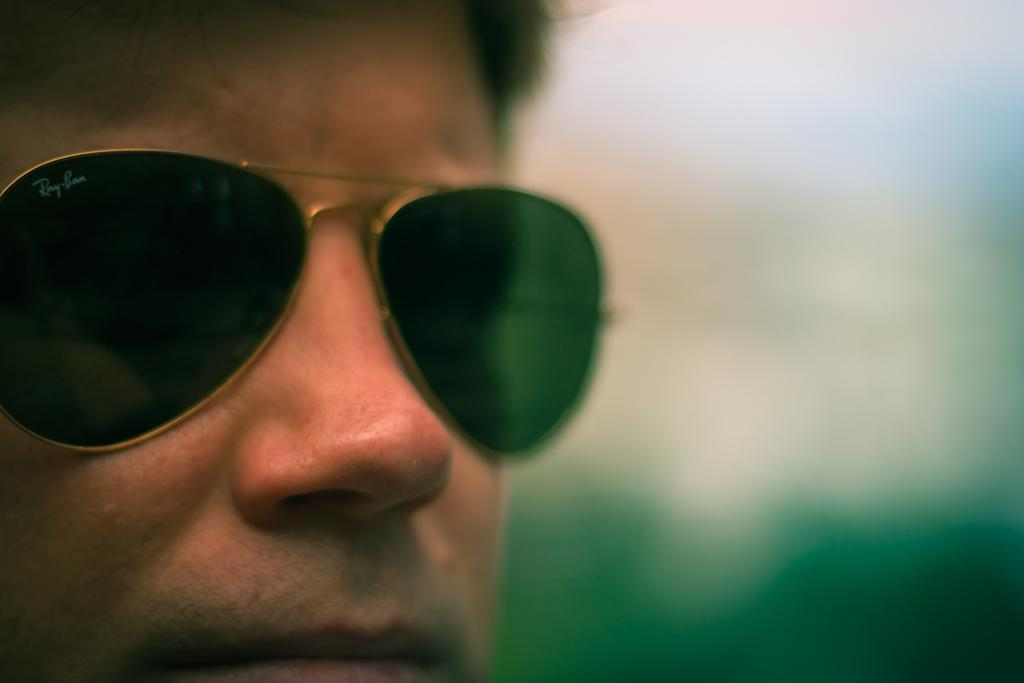What is the main subject in the foreground of the image? There is a person in the foreground of the image. What accessory is the person wearing? The person is wearing sunglasses. Can you describe the background of the image? The background of the image is blurry. What type of grip does the beast have on the toy in the image? There is no beast or toy present in the image; it features a person wearing sunglasses in a blurry background. 